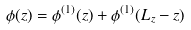<formula> <loc_0><loc_0><loc_500><loc_500>\phi ( z ) = \phi ^ { ( 1 ) } ( z ) + \phi ^ { ( 1 ) } ( L _ { z } - z )</formula> 